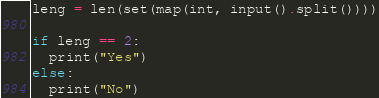<code> <loc_0><loc_0><loc_500><loc_500><_Python_>leng = len(set(map(int, input().split())))

if leng == 2:
  print("Yes")
else:
  print("No")</code> 